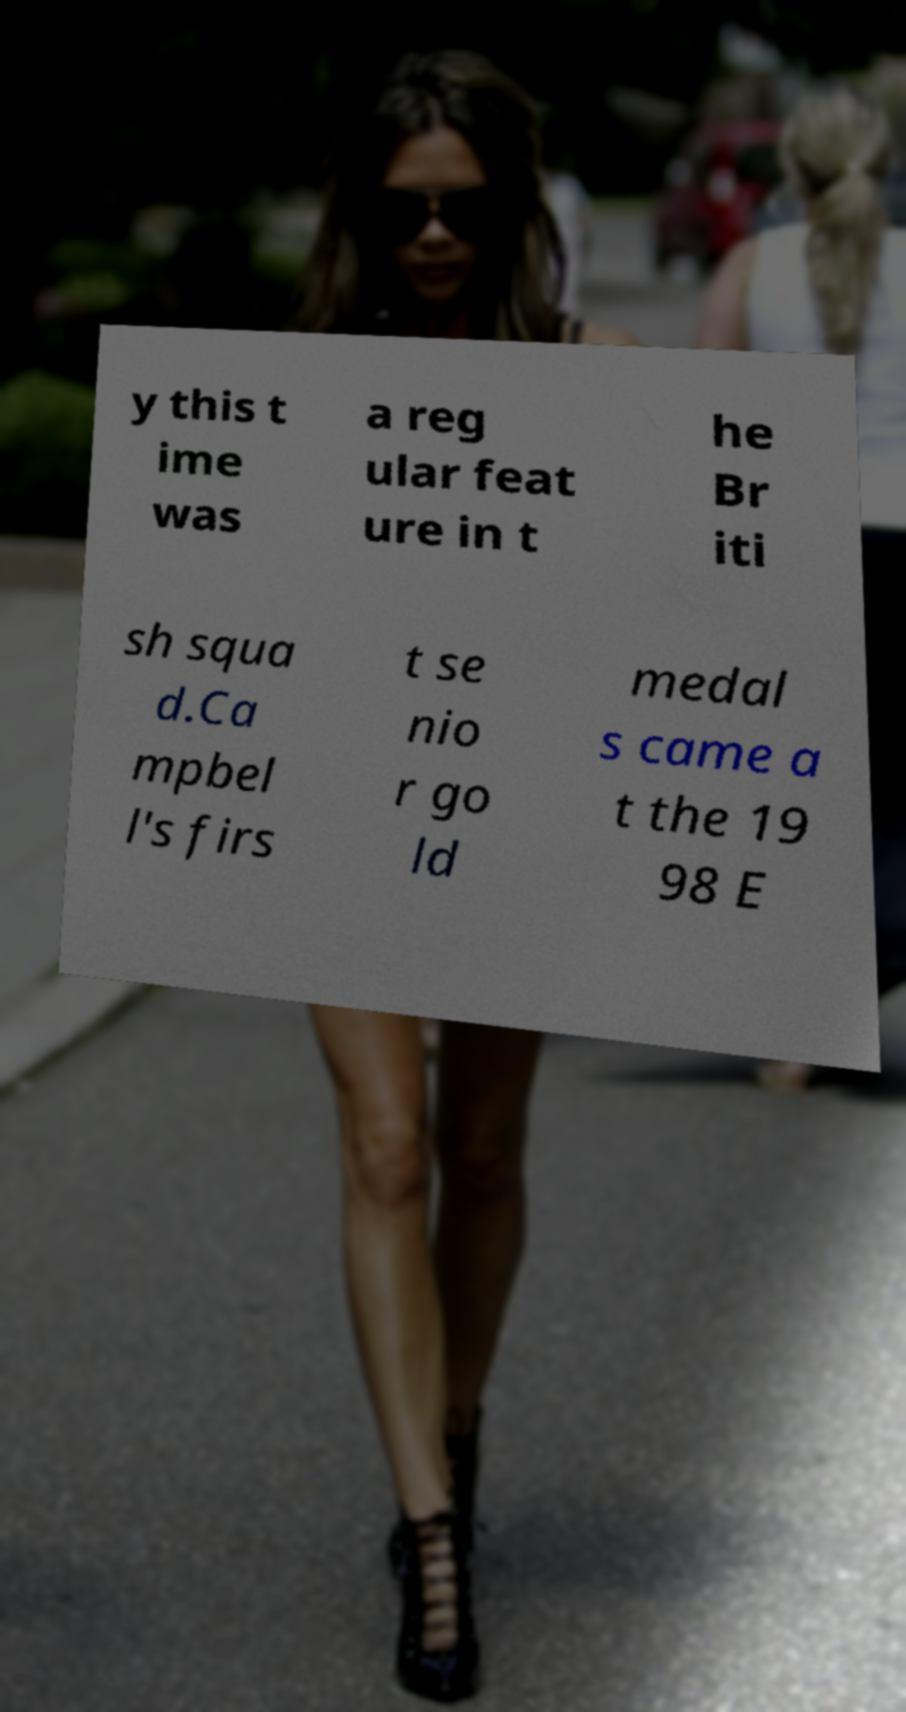Can you accurately transcribe the text from the provided image for me? y this t ime was a reg ular feat ure in t he Br iti sh squa d.Ca mpbel l's firs t se nio r go ld medal s came a t the 19 98 E 